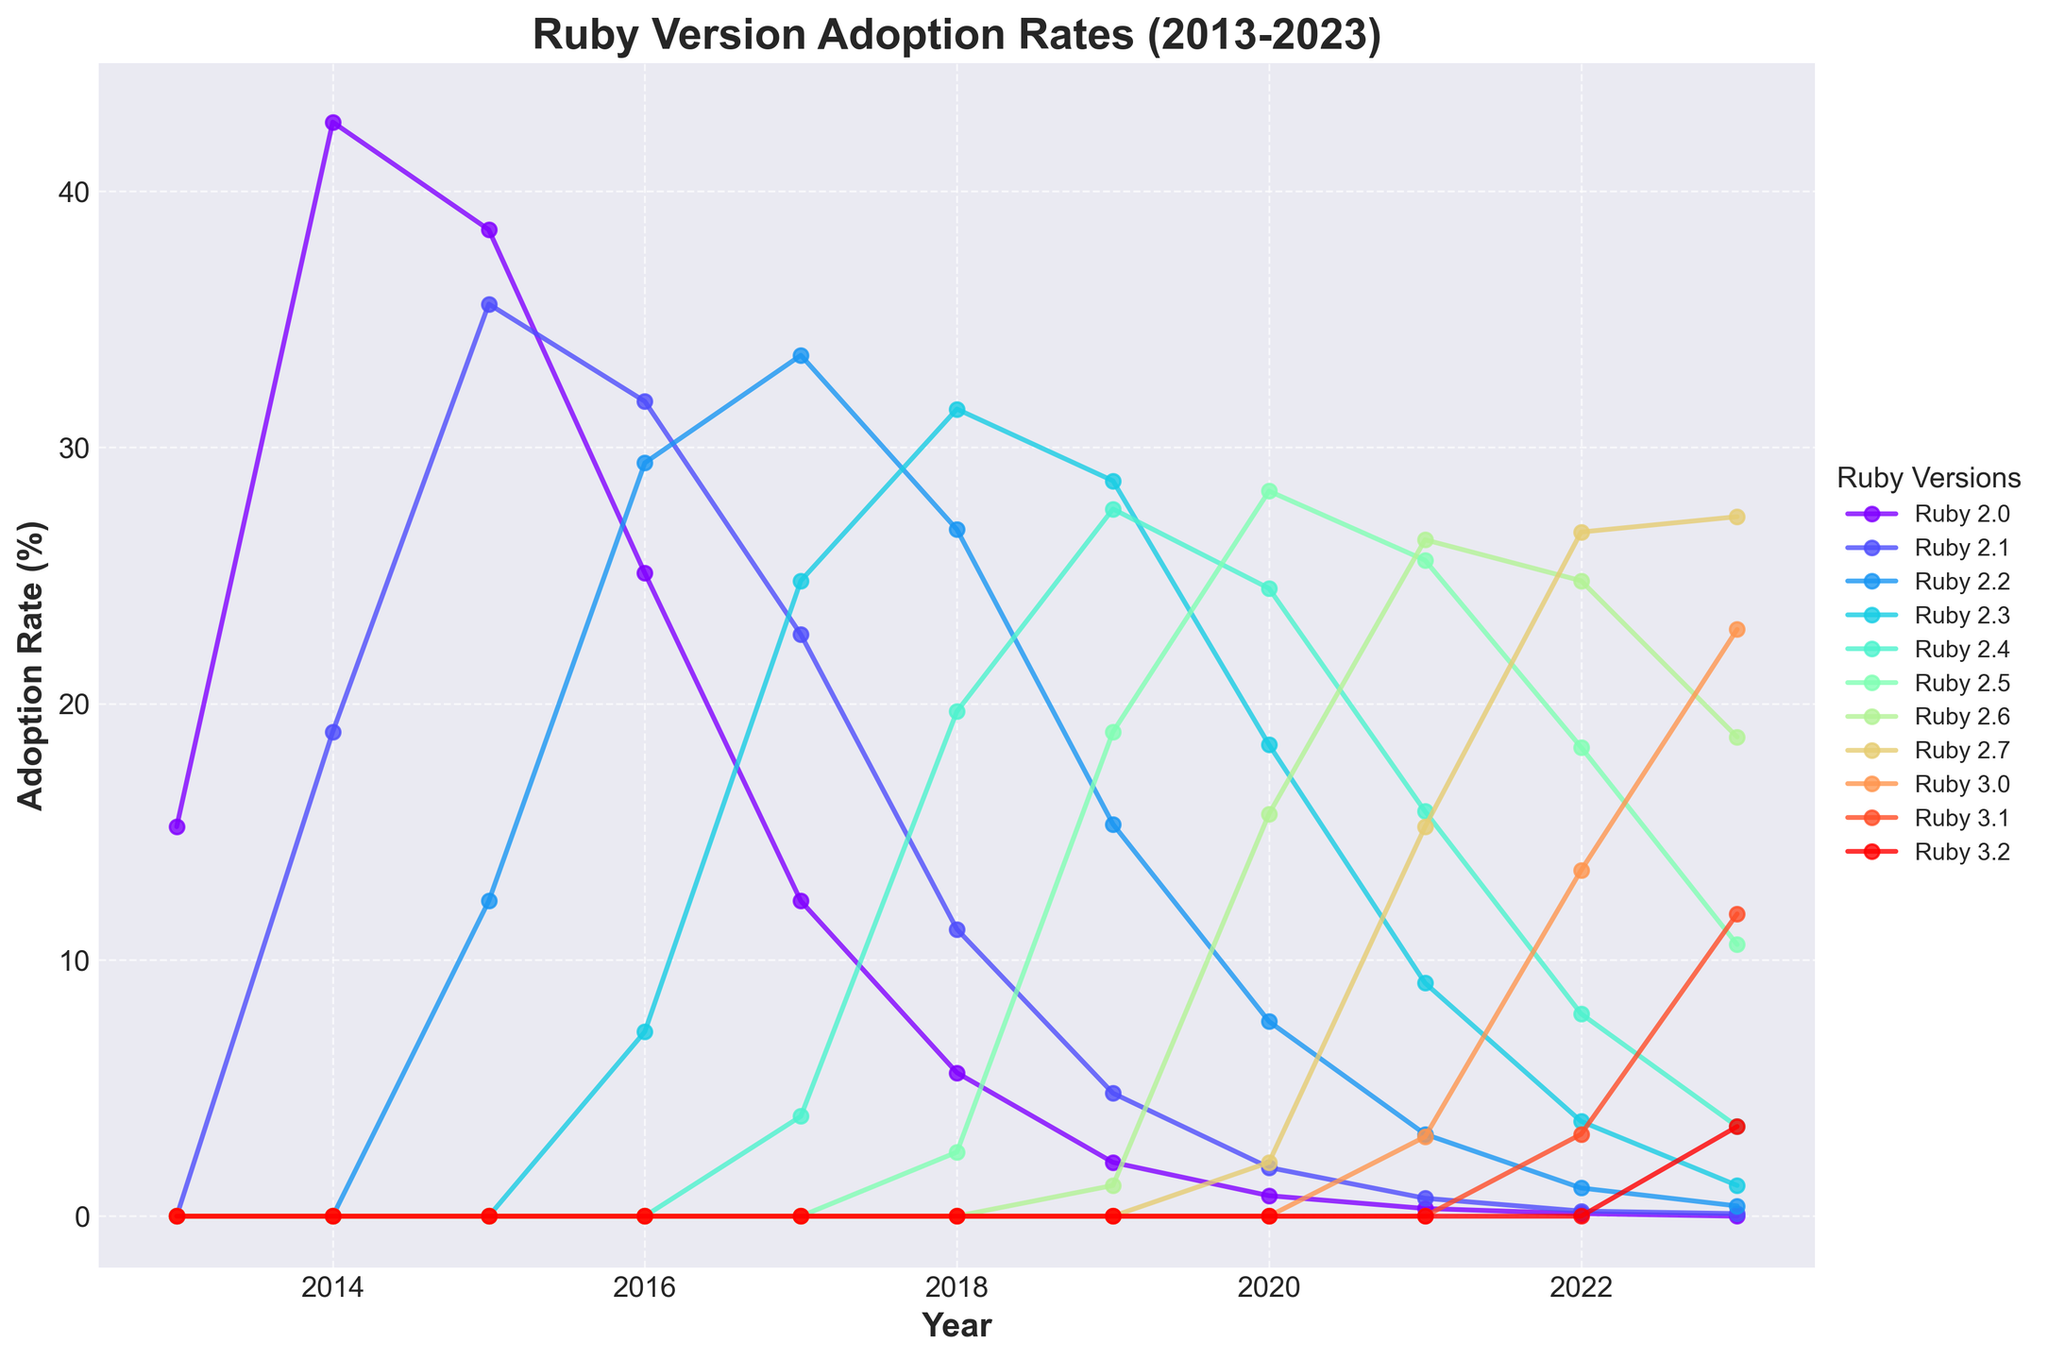What is the adoption rate of Ruby 2.6 in 2021? Look at the line representing Ruby 2.6 in the year 2021 on the chart. The adoption rate is shown as a point on the line.
Answer: 26.4% Which Ruby version had the highest adoption rate in 2014? Compare the adoption rates of all Ruby versions in 2014 by looking at the height of the lines. Ruby 2.0 has the highest adoption rate.
Answer: Ruby 2.0 How many Ruby versions have an adoption rate of at least 20% in 2019? Identify the lines above the 20% mark in 2019. Ruby 2.3 and Ruby 2.4 exceed this threshold.
Answer: 2 What is the difference in adoption rates between Ruby 2.4 and Ruby 2.7 in 2023? Subtract the adoption rate of Ruby 2.7 from that of Ruby 2.4 in 2023 by referring to their respective points on the chart.
Answer: -0.6% Which year did Ruby 2.3 first surpass a 30% adoption rate? Track the adoption rate line for Ruby 2.3 and identify the first year it is above 30%. This occurs in 2018.
Answer: 2018 What is the color of the line representing Ruby 3.0 on the chart? Identify the line for Ruby 3.0 by its label and note the color used to display it.
Answer: Green In which year did Ruby 2.5 have its peak adoption rate? Follow the Ruby 2.5 line and find the year it reaches its highest point. This peak occurs in 2020.
Answer: 2020 How much did the adoption rate of Ruby 2.1 change from 2013 to 2017? Subtract the adoption rate of Ruby 2.1 in 2013 from that in 2017 by referring to their respective points on the chart.
Answer: 22.7% Which Ruby version had an adoption rate closest to 10% in 2021? Identify the Ruby version whose adoption rate is nearest to 10% by looking at the adoption rates in 2021. Ruby 2.7 had an adoption rate of 15.2%, the closest.
Answer: Ruby 2.7 